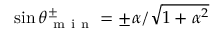Convert formula to latex. <formula><loc_0><loc_0><loc_500><loc_500>\sin { \theta _ { m i n } ^ { \pm } } = \pm \alpha / \sqrt { 1 + \alpha ^ { 2 } }</formula> 